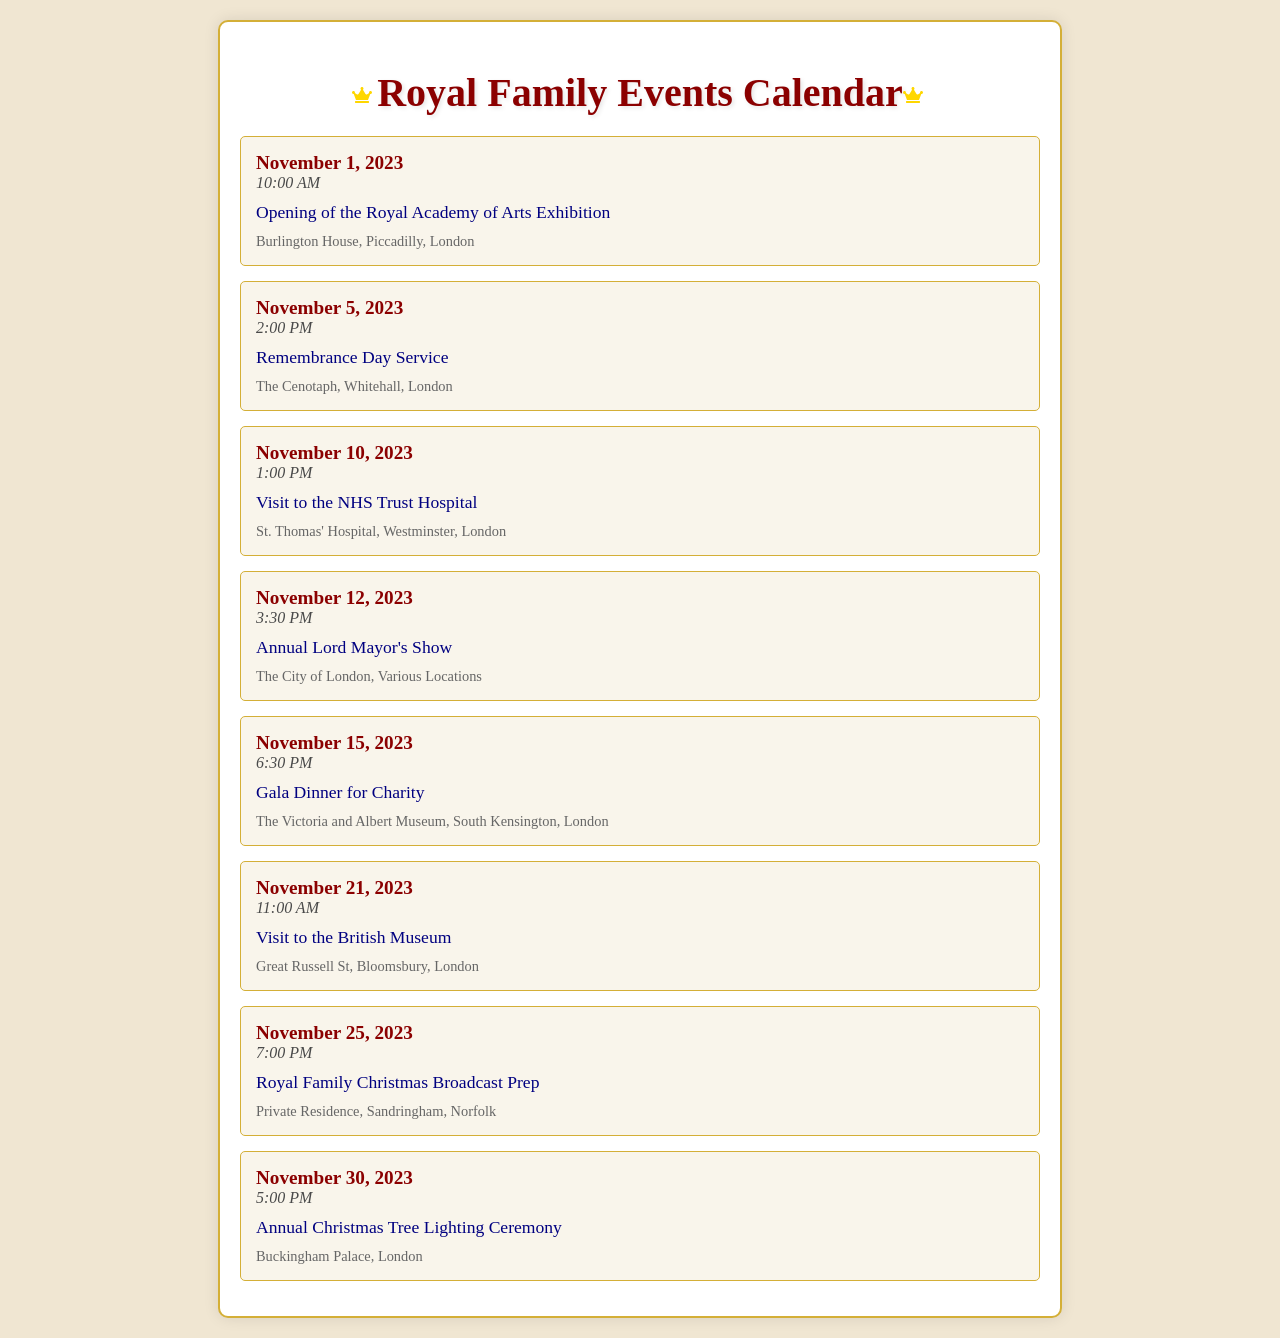What event takes place on November 1, 2023? The event listed for November 1, 2023, is the Opening of the Royal Academy of Arts Exhibition.
Answer: Opening of the Royal Academy of Arts Exhibition What time is the Remembrance Day Service scheduled? The time for the Remembrance Day Service on November 5, 2023, is 2:00 PM.
Answer: 2:00 PM Where is the Annual Christmas Tree Lighting Ceremony held? The venue for the Annual Christmas Tree Lighting Ceremony on November 30, 2023, is Buckingham Palace, London.
Answer: Buckingham Palace, London How many events are scheduled for November 2023? There are a total of eight events scheduled for November 2023 in the document provided.
Answer: 8 What is the date of the Gala Dinner for Charity? The Gala Dinner for Charity is scheduled for November 15, 2023.
Answer: November 15, 2023 Which event occurs before the Christmas Broadcast Prep? The event that occurs before the Royal Family Christmas Broadcast Prep on November 25, 2023, is the Visit to the British Museum on November 21, 2023.
Answer: Visit to the British Museum What is the earliest event listed in the document? The earliest event in the document is the Opening of the Royal Academy of Arts Exhibition on November 1, 2023.
Answer: Opening of the Royal Academy of Arts Exhibition What type of event happens on November 12, 2023? The event scheduled for November 12, 2023, is the Annual Lord Mayor's Show, which is a public event.
Answer: Annual Lord Mayor's Show 